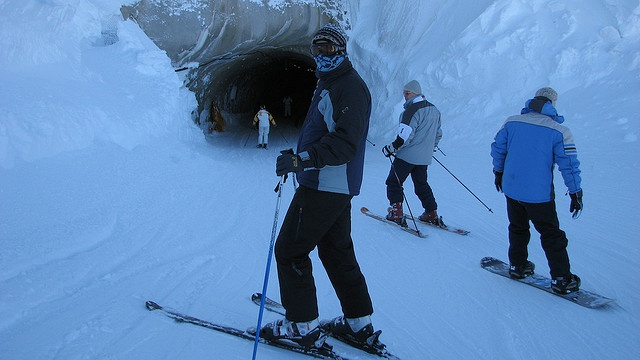Describe the objects in this image and their specific colors. I can see people in lightblue, black, navy, and gray tones, people in lightblue, black, navy, and gray tones, people in lightblue, blue, black, and navy tones, people in lightblue, black, gray, and navy tones, and skis in lightblue, darkgray, black, navy, and blue tones in this image. 